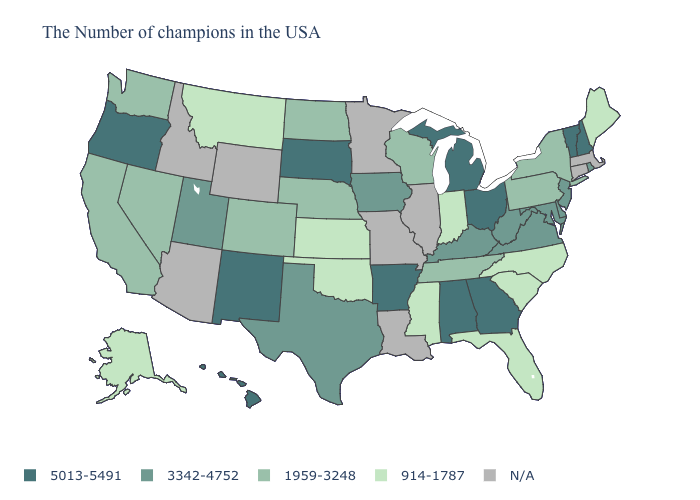What is the value of Utah?
Give a very brief answer. 3342-4752. What is the lowest value in the USA?
Short answer required. 914-1787. Name the states that have a value in the range 914-1787?
Concise answer only. Maine, North Carolina, South Carolina, Florida, Indiana, Mississippi, Kansas, Oklahoma, Montana, Alaska. Among the states that border Pennsylvania , which have the highest value?
Keep it brief. Ohio. What is the value of Arizona?
Give a very brief answer. N/A. Among the states that border New Jersey , does Delaware have the lowest value?
Concise answer only. No. Does Utah have the highest value in the West?
Quick response, please. No. Does the map have missing data?
Concise answer only. Yes. What is the value of Vermont?
Write a very short answer. 5013-5491. Name the states that have a value in the range 914-1787?
Be succinct. Maine, North Carolina, South Carolina, Florida, Indiana, Mississippi, Kansas, Oklahoma, Montana, Alaska. What is the value of Nebraska?
Answer briefly. 1959-3248. Name the states that have a value in the range 914-1787?
Keep it brief. Maine, North Carolina, South Carolina, Florida, Indiana, Mississippi, Kansas, Oklahoma, Montana, Alaska. What is the value of Missouri?
Write a very short answer. N/A. Among the states that border Michigan , does Ohio have the highest value?
Concise answer only. Yes. 